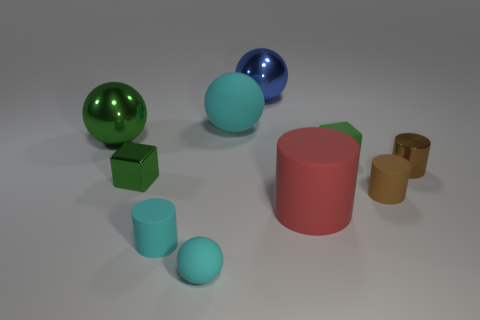There is a big matte thing on the right side of the blue metallic ball; what is its shape?
Give a very brief answer. Cylinder. There is a tiny green thing that is on the right side of the blue shiny thing; is it the same shape as the blue metal object?
Give a very brief answer. No. What number of objects are balls that are behind the red rubber object or small brown rubber cylinders?
Make the answer very short. 4. There is another big metallic object that is the same shape as the big blue metallic thing; what is its color?
Offer a terse response. Green. Is there anything else that has the same color as the rubber cube?
Provide a succinct answer. Yes. There is a metallic thing to the right of the blue shiny thing; what size is it?
Give a very brief answer. Small. Does the metallic block have the same color as the rubber ball in front of the green metallic sphere?
Keep it short and to the point. No. What number of other objects are the same material as the blue thing?
Make the answer very short. 3. Are there more brown metallic objects than tiny purple objects?
Keep it short and to the point. Yes. There is a big metal thing that is to the left of the small cyan sphere; does it have the same color as the large cylinder?
Make the answer very short. No. 